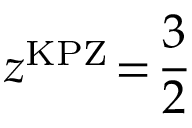Convert formula to latex. <formula><loc_0><loc_0><loc_500><loc_500>z ^ { K P Z } \, = \, \frac { 3 } { 2 }</formula> 